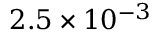Convert formula to latex. <formula><loc_0><loc_0><loc_500><loc_500>2 . 5 \times 1 0 ^ { - 3 }</formula> 